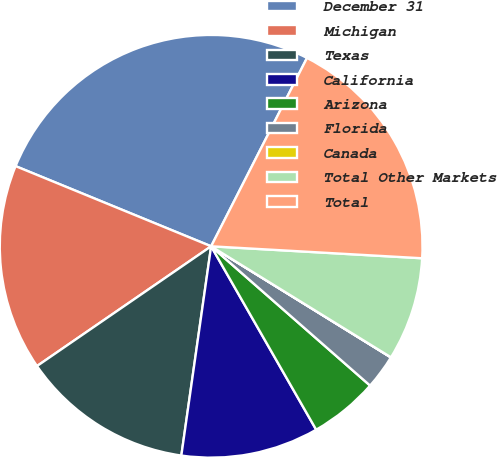Convert chart. <chart><loc_0><loc_0><loc_500><loc_500><pie_chart><fcel>December 31<fcel>Michigan<fcel>Texas<fcel>California<fcel>Arizona<fcel>Florida<fcel>Canada<fcel>Total Other Markets<fcel>Total<nl><fcel>26.3%<fcel>15.78%<fcel>13.16%<fcel>10.53%<fcel>5.27%<fcel>2.64%<fcel>0.01%<fcel>7.9%<fcel>18.41%<nl></chart> 